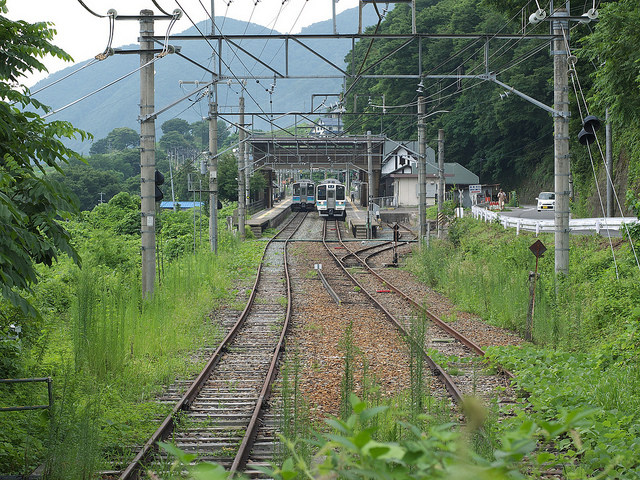Does the image suggest this railway system is used for passenger or freight trains, and how can you tell? The trains in the image look like passenger models based on their design and the presence of multiple doors for boarding, which is common in passenger trains for efficiency and convenience. In contrast, freight trains usually consist of longer, solid carriages designed for cargo and do not feature such passenger-specific designs. 